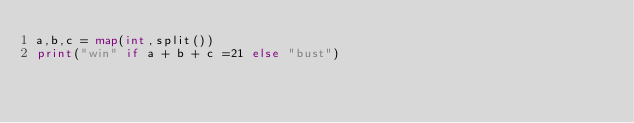Convert code to text. <code><loc_0><loc_0><loc_500><loc_500><_Python_>a,b,c = map(int,split())
print("win" if a + b + c =21 else "bust")</code> 